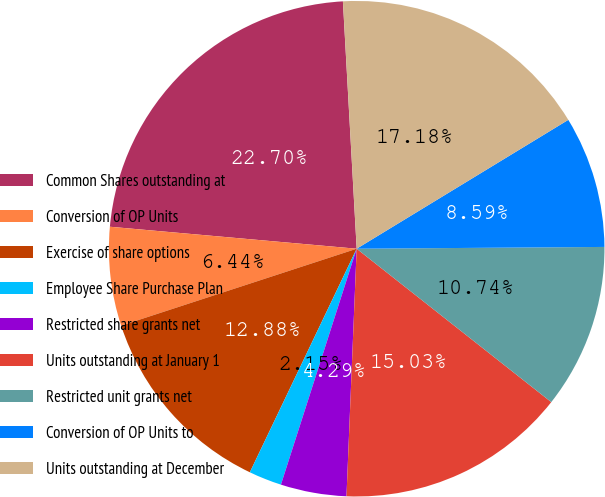<chart> <loc_0><loc_0><loc_500><loc_500><pie_chart><fcel>Common Shares outstanding at<fcel>Conversion of OP Units<fcel>Exercise of share options<fcel>Employee Share Purchase Plan<fcel>Restricted share grants net<fcel>Units outstanding at January 1<fcel>Restricted unit grants net<fcel>Conversion of OP Units to<fcel>Units outstanding at December<nl><fcel>22.7%<fcel>6.44%<fcel>12.88%<fcel>2.15%<fcel>4.29%<fcel>15.03%<fcel>10.74%<fcel>8.59%<fcel>17.18%<nl></chart> 